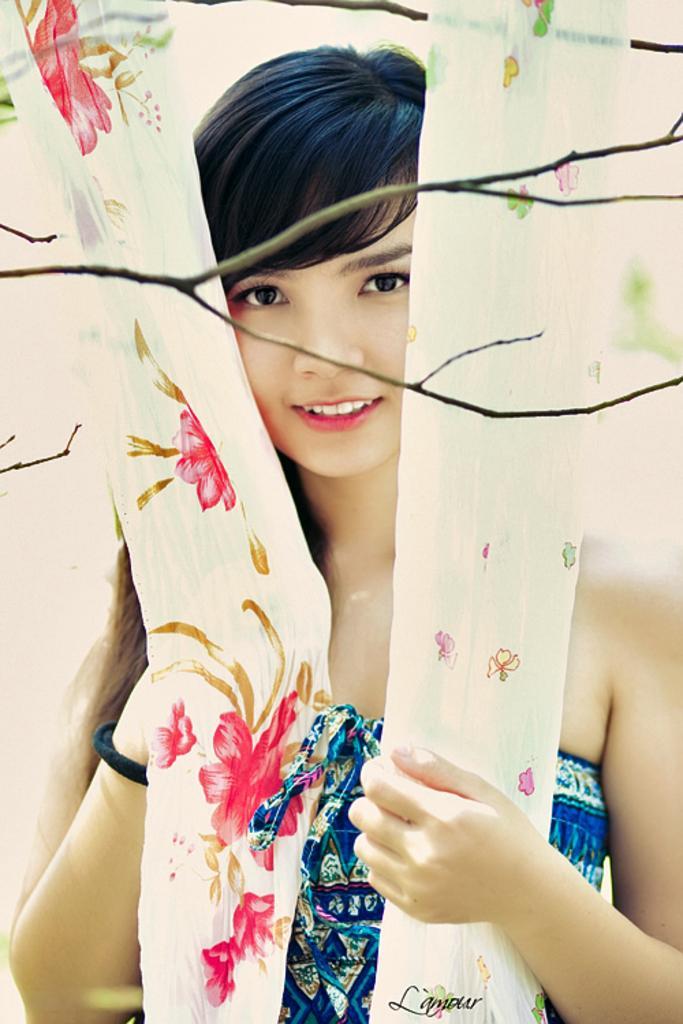How would you summarize this image in a sentence or two? In this picture we can see a beautiful woman wearing a blue dress and a black band to her wrist. She is smiling. These are colorful curtains. Here we can see twigs. 